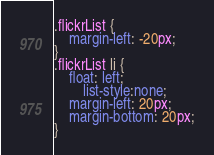<code> <loc_0><loc_0><loc_500><loc_500><_CSS_>.flickrList {
	margin-left: -20px;
}
.flickrList li {
	float: left;
        list-style:none;
	margin-left: 20px;
	margin-bottom: 20px;
}</code> 